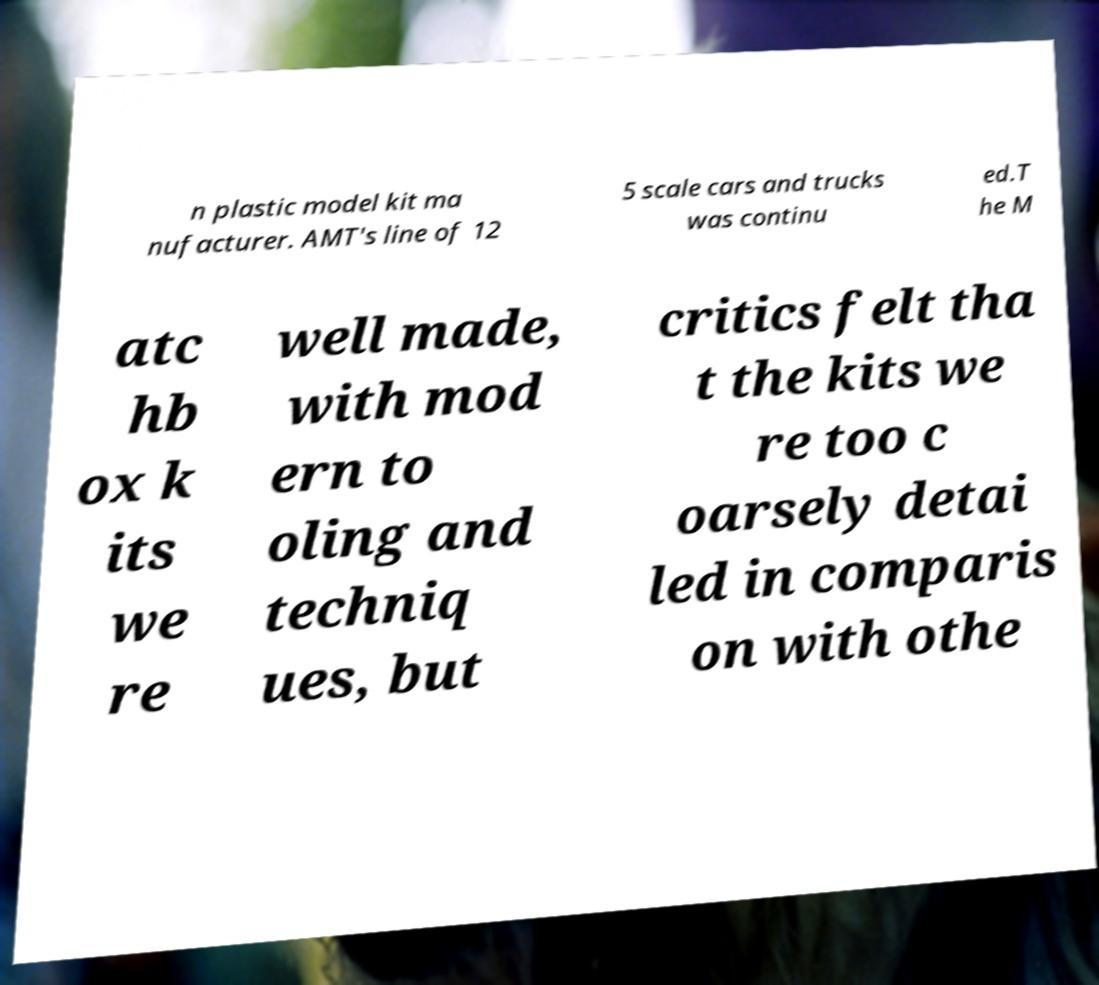Could you assist in decoding the text presented in this image and type it out clearly? n plastic model kit ma nufacturer. AMT's line of 12 5 scale cars and trucks was continu ed.T he M atc hb ox k its we re well made, with mod ern to oling and techniq ues, but critics felt tha t the kits we re too c oarsely detai led in comparis on with othe 